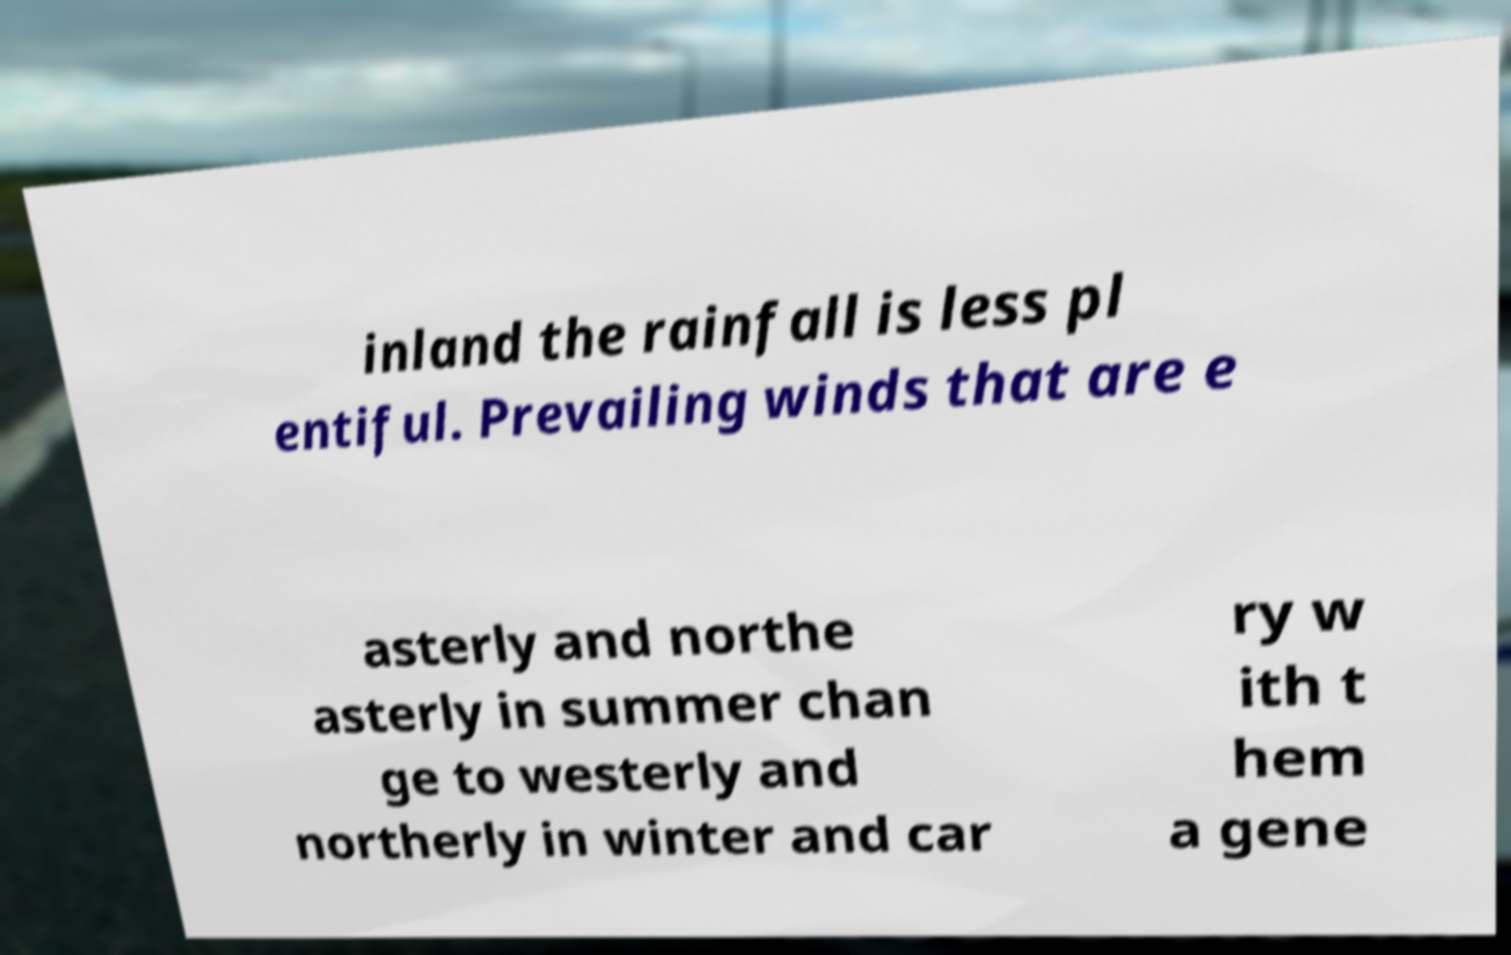Please read and relay the text visible in this image. What does it say? inland the rainfall is less pl entiful. Prevailing winds that are e asterly and northe asterly in summer chan ge to westerly and northerly in winter and car ry w ith t hem a gene 